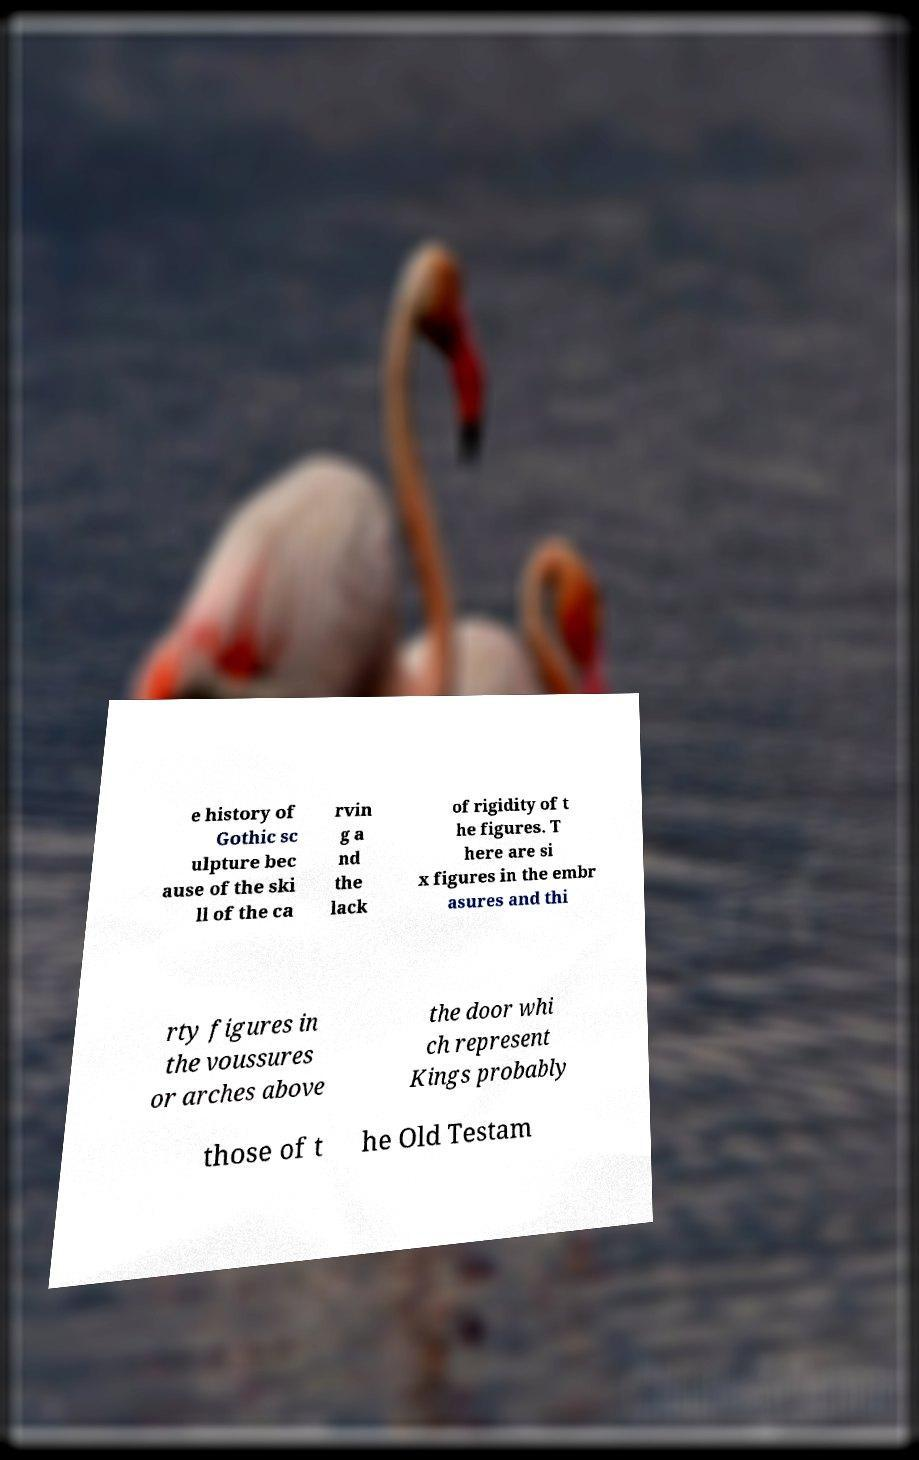What messages or text are displayed in this image? I need them in a readable, typed format. e history of Gothic sc ulpture bec ause of the ski ll of the ca rvin g a nd the lack of rigidity of t he figures. T here are si x figures in the embr asures and thi rty figures in the voussures or arches above the door whi ch represent Kings probably those of t he Old Testam 